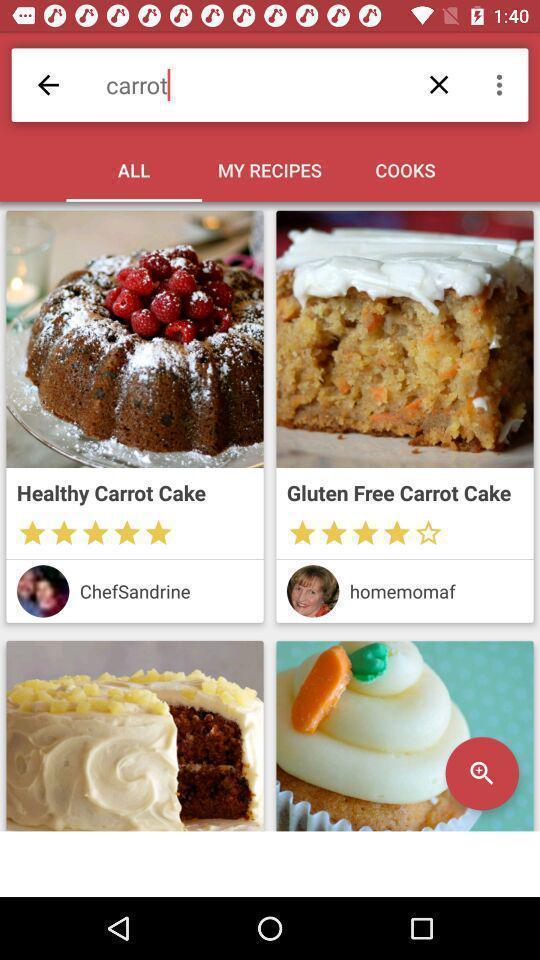Explain what's happening in this screen capture. Page showing different recipes available. 